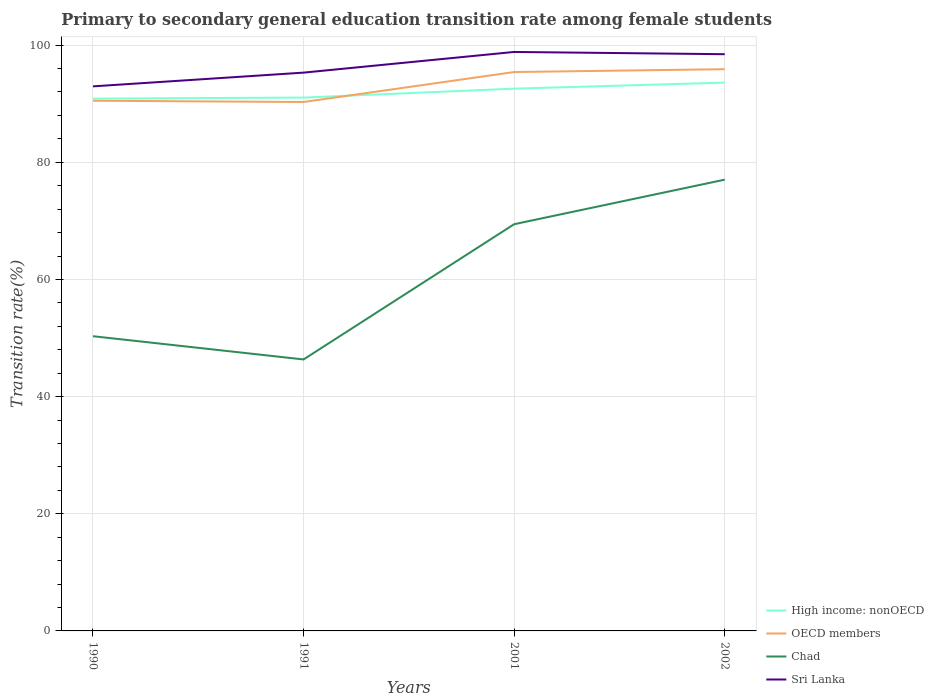Does the line corresponding to High income: nonOECD intersect with the line corresponding to Sri Lanka?
Your answer should be very brief. No. Across all years, what is the maximum transition rate in Sri Lanka?
Keep it short and to the point. 92.96. In which year was the transition rate in Sri Lanka maximum?
Offer a very short reply. 1990. What is the total transition rate in OECD members in the graph?
Keep it short and to the point. -5.38. What is the difference between the highest and the second highest transition rate in Sri Lanka?
Give a very brief answer. 5.87. What is the difference between the highest and the lowest transition rate in OECD members?
Your answer should be very brief. 2. What is the difference between two consecutive major ticks on the Y-axis?
Your response must be concise. 20. Are the values on the major ticks of Y-axis written in scientific E-notation?
Provide a short and direct response. No. Does the graph contain any zero values?
Make the answer very short. No. Does the graph contain grids?
Ensure brevity in your answer.  Yes. What is the title of the graph?
Give a very brief answer. Primary to secondary general education transition rate among female students. Does "Monaco" appear as one of the legend labels in the graph?
Make the answer very short. No. What is the label or title of the Y-axis?
Make the answer very short. Transition rate(%). What is the Transition rate(%) of High income: nonOECD in 1990?
Offer a very short reply. 90.87. What is the Transition rate(%) in OECD members in 1990?
Ensure brevity in your answer.  90.51. What is the Transition rate(%) of Chad in 1990?
Give a very brief answer. 50.31. What is the Transition rate(%) of Sri Lanka in 1990?
Ensure brevity in your answer.  92.96. What is the Transition rate(%) of High income: nonOECD in 1991?
Offer a very short reply. 91.05. What is the Transition rate(%) in OECD members in 1991?
Offer a terse response. 90.29. What is the Transition rate(%) in Chad in 1991?
Make the answer very short. 46.34. What is the Transition rate(%) in Sri Lanka in 1991?
Ensure brevity in your answer.  95.31. What is the Transition rate(%) of High income: nonOECD in 2001?
Your answer should be compact. 92.57. What is the Transition rate(%) of OECD members in 2001?
Ensure brevity in your answer.  95.41. What is the Transition rate(%) in Chad in 2001?
Keep it short and to the point. 69.43. What is the Transition rate(%) of Sri Lanka in 2001?
Your answer should be compact. 98.84. What is the Transition rate(%) in High income: nonOECD in 2002?
Provide a succinct answer. 93.6. What is the Transition rate(%) in OECD members in 2002?
Make the answer very short. 95.89. What is the Transition rate(%) of Chad in 2002?
Your response must be concise. 77.03. What is the Transition rate(%) in Sri Lanka in 2002?
Offer a very short reply. 98.45. Across all years, what is the maximum Transition rate(%) in High income: nonOECD?
Provide a succinct answer. 93.6. Across all years, what is the maximum Transition rate(%) in OECD members?
Provide a succinct answer. 95.89. Across all years, what is the maximum Transition rate(%) of Chad?
Give a very brief answer. 77.03. Across all years, what is the maximum Transition rate(%) in Sri Lanka?
Your answer should be very brief. 98.84. Across all years, what is the minimum Transition rate(%) in High income: nonOECD?
Ensure brevity in your answer.  90.87. Across all years, what is the minimum Transition rate(%) in OECD members?
Give a very brief answer. 90.29. Across all years, what is the minimum Transition rate(%) of Chad?
Your answer should be very brief. 46.34. Across all years, what is the minimum Transition rate(%) in Sri Lanka?
Offer a very short reply. 92.96. What is the total Transition rate(%) in High income: nonOECD in the graph?
Your response must be concise. 368.09. What is the total Transition rate(%) of OECD members in the graph?
Offer a very short reply. 372.1. What is the total Transition rate(%) of Chad in the graph?
Offer a terse response. 243.12. What is the total Transition rate(%) in Sri Lanka in the graph?
Offer a very short reply. 385.55. What is the difference between the Transition rate(%) of High income: nonOECD in 1990 and that in 1991?
Keep it short and to the point. -0.18. What is the difference between the Transition rate(%) of OECD members in 1990 and that in 1991?
Your response must be concise. 0.22. What is the difference between the Transition rate(%) in Chad in 1990 and that in 1991?
Your answer should be very brief. 3.97. What is the difference between the Transition rate(%) in Sri Lanka in 1990 and that in 1991?
Offer a very short reply. -2.34. What is the difference between the Transition rate(%) in High income: nonOECD in 1990 and that in 2001?
Your answer should be very brief. -1.7. What is the difference between the Transition rate(%) of OECD members in 1990 and that in 2001?
Provide a succinct answer. -4.9. What is the difference between the Transition rate(%) in Chad in 1990 and that in 2001?
Your answer should be compact. -19.12. What is the difference between the Transition rate(%) of Sri Lanka in 1990 and that in 2001?
Your answer should be very brief. -5.87. What is the difference between the Transition rate(%) of High income: nonOECD in 1990 and that in 2002?
Keep it short and to the point. -2.73. What is the difference between the Transition rate(%) in OECD members in 1990 and that in 2002?
Ensure brevity in your answer.  -5.38. What is the difference between the Transition rate(%) of Chad in 1990 and that in 2002?
Provide a short and direct response. -26.73. What is the difference between the Transition rate(%) in Sri Lanka in 1990 and that in 2002?
Keep it short and to the point. -5.49. What is the difference between the Transition rate(%) of High income: nonOECD in 1991 and that in 2001?
Keep it short and to the point. -1.52. What is the difference between the Transition rate(%) in OECD members in 1991 and that in 2001?
Provide a succinct answer. -5.12. What is the difference between the Transition rate(%) of Chad in 1991 and that in 2001?
Your answer should be compact. -23.09. What is the difference between the Transition rate(%) in Sri Lanka in 1991 and that in 2001?
Offer a very short reply. -3.53. What is the difference between the Transition rate(%) of High income: nonOECD in 1991 and that in 2002?
Your answer should be compact. -2.55. What is the difference between the Transition rate(%) in OECD members in 1991 and that in 2002?
Make the answer very short. -5.6. What is the difference between the Transition rate(%) of Chad in 1991 and that in 2002?
Offer a very short reply. -30.69. What is the difference between the Transition rate(%) in Sri Lanka in 1991 and that in 2002?
Make the answer very short. -3.14. What is the difference between the Transition rate(%) of High income: nonOECD in 2001 and that in 2002?
Provide a succinct answer. -1.03. What is the difference between the Transition rate(%) in OECD members in 2001 and that in 2002?
Give a very brief answer. -0.48. What is the difference between the Transition rate(%) in Chad in 2001 and that in 2002?
Your response must be concise. -7.6. What is the difference between the Transition rate(%) of Sri Lanka in 2001 and that in 2002?
Your response must be concise. 0.39. What is the difference between the Transition rate(%) in High income: nonOECD in 1990 and the Transition rate(%) in OECD members in 1991?
Your response must be concise. 0.58. What is the difference between the Transition rate(%) in High income: nonOECD in 1990 and the Transition rate(%) in Chad in 1991?
Provide a succinct answer. 44.53. What is the difference between the Transition rate(%) in High income: nonOECD in 1990 and the Transition rate(%) in Sri Lanka in 1991?
Make the answer very short. -4.44. What is the difference between the Transition rate(%) in OECD members in 1990 and the Transition rate(%) in Chad in 1991?
Keep it short and to the point. 44.17. What is the difference between the Transition rate(%) of OECD members in 1990 and the Transition rate(%) of Sri Lanka in 1991?
Your response must be concise. -4.8. What is the difference between the Transition rate(%) in Chad in 1990 and the Transition rate(%) in Sri Lanka in 1991?
Provide a succinct answer. -45. What is the difference between the Transition rate(%) of High income: nonOECD in 1990 and the Transition rate(%) of OECD members in 2001?
Give a very brief answer. -4.54. What is the difference between the Transition rate(%) in High income: nonOECD in 1990 and the Transition rate(%) in Chad in 2001?
Offer a terse response. 21.44. What is the difference between the Transition rate(%) in High income: nonOECD in 1990 and the Transition rate(%) in Sri Lanka in 2001?
Give a very brief answer. -7.97. What is the difference between the Transition rate(%) of OECD members in 1990 and the Transition rate(%) of Chad in 2001?
Keep it short and to the point. 21.08. What is the difference between the Transition rate(%) of OECD members in 1990 and the Transition rate(%) of Sri Lanka in 2001?
Your response must be concise. -8.33. What is the difference between the Transition rate(%) in Chad in 1990 and the Transition rate(%) in Sri Lanka in 2001?
Ensure brevity in your answer.  -48.53. What is the difference between the Transition rate(%) in High income: nonOECD in 1990 and the Transition rate(%) in OECD members in 2002?
Make the answer very short. -5.02. What is the difference between the Transition rate(%) of High income: nonOECD in 1990 and the Transition rate(%) of Chad in 2002?
Your answer should be compact. 13.84. What is the difference between the Transition rate(%) of High income: nonOECD in 1990 and the Transition rate(%) of Sri Lanka in 2002?
Keep it short and to the point. -7.58. What is the difference between the Transition rate(%) of OECD members in 1990 and the Transition rate(%) of Chad in 2002?
Keep it short and to the point. 13.47. What is the difference between the Transition rate(%) of OECD members in 1990 and the Transition rate(%) of Sri Lanka in 2002?
Your answer should be very brief. -7.94. What is the difference between the Transition rate(%) in Chad in 1990 and the Transition rate(%) in Sri Lanka in 2002?
Give a very brief answer. -48.14. What is the difference between the Transition rate(%) in High income: nonOECD in 1991 and the Transition rate(%) in OECD members in 2001?
Your response must be concise. -4.36. What is the difference between the Transition rate(%) of High income: nonOECD in 1991 and the Transition rate(%) of Chad in 2001?
Ensure brevity in your answer.  21.62. What is the difference between the Transition rate(%) of High income: nonOECD in 1991 and the Transition rate(%) of Sri Lanka in 2001?
Your answer should be very brief. -7.79. What is the difference between the Transition rate(%) of OECD members in 1991 and the Transition rate(%) of Chad in 2001?
Provide a succinct answer. 20.86. What is the difference between the Transition rate(%) in OECD members in 1991 and the Transition rate(%) in Sri Lanka in 2001?
Make the answer very short. -8.54. What is the difference between the Transition rate(%) in Chad in 1991 and the Transition rate(%) in Sri Lanka in 2001?
Make the answer very short. -52.49. What is the difference between the Transition rate(%) in High income: nonOECD in 1991 and the Transition rate(%) in OECD members in 2002?
Your answer should be compact. -4.85. What is the difference between the Transition rate(%) in High income: nonOECD in 1991 and the Transition rate(%) in Chad in 2002?
Your response must be concise. 14.01. What is the difference between the Transition rate(%) of High income: nonOECD in 1991 and the Transition rate(%) of Sri Lanka in 2002?
Keep it short and to the point. -7.4. What is the difference between the Transition rate(%) in OECD members in 1991 and the Transition rate(%) in Chad in 2002?
Offer a very short reply. 13.26. What is the difference between the Transition rate(%) of OECD members in 1991 and the Transition rate(%) of Sri Lanka in 2002?
Your answer should be very brief. -8.16. What is the difference between the Transition rate(%) of Chad in 1991 and the Transition rate(%) of Sri Lanka in 2002?
Ensure brevity in your answer.  -52.11. What is the difference between the Transition rate(%) in High income: nonOECD in 2001 and the Transition rate(%) in OECD members in 2002?
Provide a short and direct response. -3.32. What is the difference between the Transition rate(%) in High income: nonOECD in 2001 and the Transition rate(%) in Chad in 2002?
Make the answer very short. 15.54. What is the difference between the Transition rate(%) in High income: nonOECD in 2001 and the Transition rate(%) in Sri Lanka in 2002?
Offer a very short reply. -5.88. What is the difference between the Transition rate(%) of OECD members in 2001 and the Transition rate(%) of Chad in 2002?
Keep it short and to the point. 18.37. What is the difference between the Transition rate(%) in OECD members in 2001 and the Transition rate(%) in Sri Lanka in 2002?
Give a very brief answer. -3.04. What is the difference between the Transition rate(%) in Chad in 2001 and the Transition rate(%) in Sri Lanka in 2002?
Give a very brief answer. -29.02. What is the average Transition rate(%) of High income: nonOECD per year?
Provide a short and direct response. 92.02. What is the average Transition rate(%) in OECD members per year?
Provide a succinct answer. 93.03. What is the average Transition rate(%) of Chad per year?
Provide a succinct answer. 60.78. What is the average Transition rate(%) in Sri Lanka per year?
Ensure brevity in your answer.  96.39. In the year 1990, what is the difference between the Transition rate(%) of High income: nonOECD and Transition rate(%) of OECD members?
Your answer should be very brief. 0.36. In the year 1990, what is the difference between the Transition rate(%) in High income: nonOECD and Transition rate(%) in Chad?
Give a very brief answer. 40.56. In the year 1990, what is the difference between the Transition rate(%) in High income: nonOECD and Transition rate(%) in Sri Lanka?
Ensure brevity in your answer.  -2.09. In the year 1990, what is the difference between the Transition rate(%) of OECD members and Transition rate(%) of Chad?
Provide a short and direct response. 40.2. In the year 1990, what is the difference between the Transition rate(%) in OECD members and Transition rate(%) in Sri Lanka?
Provide a succinct answer. -2.45. In the year 1990, what is the difference between the Transition rate(%) in Chad and Transition rate(%) in Sri Lanka?
Ensure brevity in your answer.  -42.65. In the year 1991, what is the difference between the Transition rate(%) of High income: nonOECD and Transition rate(%) of OECD members?
Your response must be concise. 0.75. In the year 1991, what is the difference between the Transition rate(%) of High income: nonOECD and Transition rate(%) of Chad?
Provide a succinct answer. 44.7. In the year 1991, what is the difference between the Transition rate(%) in High income: nonOECD and Transition rate(%) in Sri Lanka?
Make the answer very short. -4.26. In the year 1991, what is the difference between the Transition rate(%) in OECD members and Transition rate(%) in Chad?
Your answer should be very brief. 43.95. In the year 1991, what is the difference between the Transition rate(%) of OECD members and Transition rate(%) of Sri Lanka?
Keep it short and to the point. -5.01. In the year 1991, what is the difference between the Transition rate(%) of Chad and Transition rate(%) of Sri Lanka?
Your answer should be compact. -48.96. In the year 2001, what is the difference between the Transition rate(%) in High income: nonOECD and Transition rate(%) in OECD members?
Your answer should be very brief. -2.84. In the year 2001, what is the difference between the Transition rate(%) in High income: nonOECD and Transition rate(%) in Chad?
Ensure brevity in your answer.  23.14. In the year 2001, what is the difference between the Transition rate(%) of High income: nonOECD and Transition rate(%) of Sri Lanka?
Your response must be concise. -6.27. In the year 2001, what is the difference between the Transition rate(%) of OECD members and Transition rate(%) of Chad?
Offer a terse response. 25.98. In the year 2001, what is the difference between the Transition rate(%) in OECD members and Transition rate(%) in Sri Lanka?
Offer a terse response. -3.43. In the year 2001, what is the difference between the Transition rate(%) of Chad and Transition rate(%) of Sri Lanka?
Your answer should be compact. -29.41. In the year 2002, what is the difference between the Transition rate(%) in High income: nonOECD and Transition rate(%) in OECD members?
Ensure brevity in your answer.  -2.29. In the year 2002, what is the difference between the Transition rate(%) of High income: nonOECD and Transition rate(%) of Chad?
Your answer should be very brief. 16.56. In the year 2002, what is the difference between the Transition rate(%) in High income: nonOECD and Transition rate(%) in Sri Lanka?
Your answer should be compact. -4.85. In the year 2002, what is the difference between the Transition rate(%) of OECD members and Transition rate(%) of Chad?
Your answer should be very brief. 18.86. In the year 2002, what is the difference between the Transition rate(%) of OECD members and Transition rate(%) of Sri Lanka?
Provide a succinct answer. -2.56. In the year 2002, what is the difference between the Transition rate(%) in Chad and Transition rate(%) in Sri Lanka?
Make the answer very short. -21.42. What is the ratio of the Transition rate(%) of High income: nonOECD in 1990 to that in 1991?
Your answer should be very brief. 1. What is the ratio of the Transition rate(%) in Chad in 1990 to that in 1991?
Your answer should be very brief. 1.09. What is the ratio of the Transition rate(%) in Sri Lanka in 1990 to that in 1991?
Your response must be concise. 0.98. What is the ratio of the Transition rate(%) in High income: nonOECD in 1990 to that in 2001?
Provide a short and direct response. 0.98. What is the ratio of the Transition rate(%) in OECD members in 1990 to that in 2001?
Give a very brief answer. 0.95. What is the ratio of the Transition rate(%) in Chad in 1990 to that in 2001?
Provide a short and direct response. 0.72. What is the ratio of the Transition rate(%) of Sri Lanka in 1990 to that in 2001?
Keep it short and to the point. 0.94. What is the ratio of the Transition rate(%) in High income: nonOECD in 1990 to that in 2002?
Keep it short and to the point. 0.97. What is the ratio of the Transition rate(%) of OECD members in 1990 to that in 2002?
Your answer should be very brief. 0.94. What is the ratio of the Transition rate(%) in Chad in 1990 to that in 2002?
Provide a short and direct response. 0.65. What is the ratio of the Transition rate(%) of Sri Lanka in 1990 to that in 2002?
Offer a terse response. 0.94. What is the ratio of the Transition rate(%) of High income: nonOECD in 1991 to that in 2001?
Give a very brief answer. 0.98. What is the ratio of the Transition rate(%) of OECD members in 1991 to that in 2001?
Give a very brief answer. 0.95. What is the ratio of the Transition rate(%) in Chad in 1991 to that in 2001?
Your answer should be compact. 0.67. What is the ratio of the Transition rate(%) of High income: nonOECD in 1991 to that in 2002?
Your answer should be very brief. 0.97. What is the ratio of the Transition rate(%) of OECD members in 1991 to that in 2002?
Your response must be concise. 0.94. What is the ratio of the Transition rate(%) of Chad in 1991 to that in 2002?
Offer a terse response. 0.6. What is the ratio of the Transition rate(%) in Sri Lanka in 1991 to that in 2002?
Your answer should be very brief. 0.97. What is the ratio of the Transition rate(%) in High income: nonOECD in 2001 to that in 2002?
Offer a very short reply. 0.99. What is the ratio of the Transition rate(%) in OECD members in 2001 to that in 2002?
Provide a short and direct response. 0.99. What is the ratio of the Transition rate(%) of Chad in 2001 to that in 2002?
Your response must be concise. 0.9. What is the difference between the highest and the second highest Transition rate(%) in High income: nonOECD?
Your answer should be compact. 1.03. What is the difference between the highest and the second highest Transition rate(%) of OECD members?
Your answer should be very brief. 0.48. What is the difference between the highest and the second highest Transition rate(%) in Chad?
Your answer should be compact. 7.6. What is the difference between the highest and the second highest Transition rate(%) of Sri Lanka?
Offer a terse response. 0.39. What is the difference between the highest and the lowest Transition rate(%) in High income: nonOECD?
Your answer should be compact. 2.73. What is the difference between the highest and the lowest Transition rate(%) of OECD members?
Provide a succinct answer. 5.6. What is the difference between the highest and the lowest Transition rate(%) in Chad?
Keep it short and to the point. 30.69. What is the difference between the highest and the lowest Transition rate(%) in Sri Lanka?
Keep it short and to the point. 5.87. 